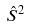<formula> <loc_0><loc_0><loc_500><loc_500>\hat { S } ^ { 2 }</formula> 